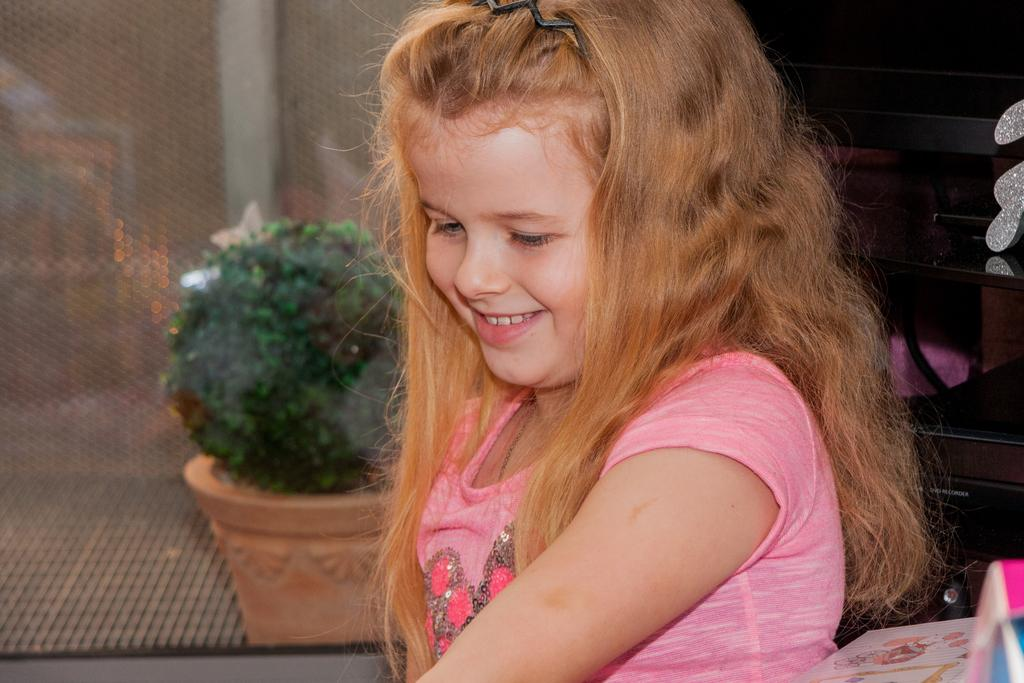Who is present in the image? There is a girl in the image. What is the girl's expression? The girl is smiling. What can be seen near the girl? There is a flower pot with a plant in the image. Can you describe any other objects in the image? There are some objects in the image, but their specific details are not mentioned in the provided facts. What type of dog is wearing a mask and showing its teeth in the image? There is no dog, mask, or teeth present in the image; it features a girl and a flower pot with a plant. 